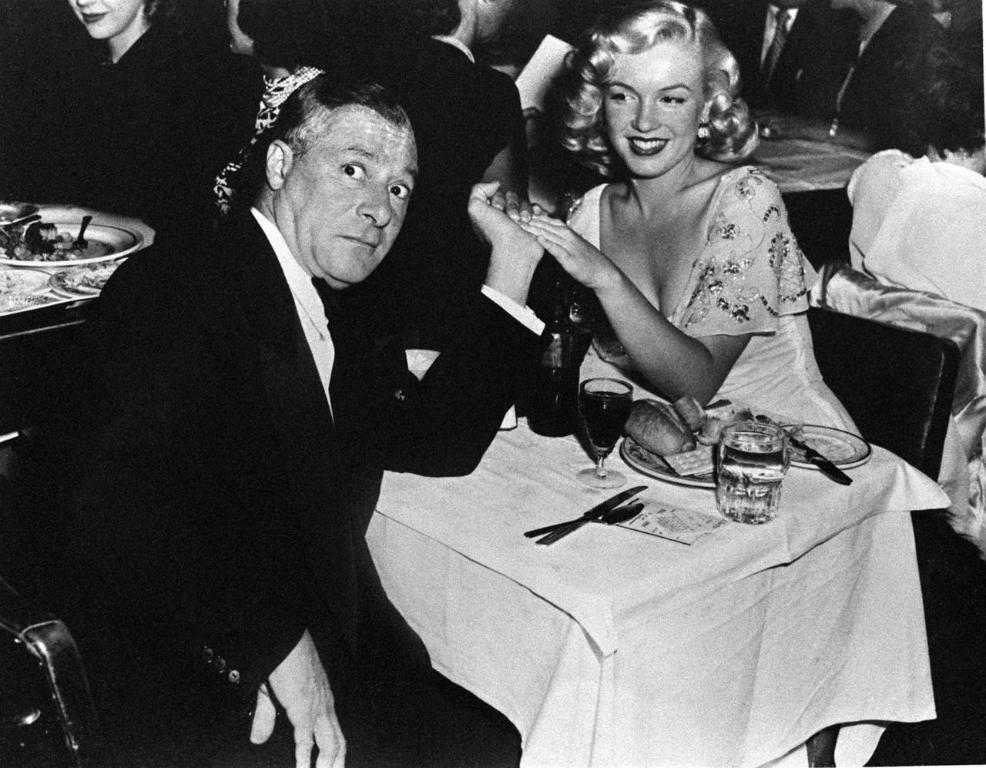What is the color scheme of the image? The image is black and white. Who or what can be seen in the image? There are people in the image. What objects are present in the image that are typically used for eating or drinking? There are glasses, plates, and knives in the image. What is the primary setting of the image? There are objects on tables in the image, suggesting a dining or eating area. What else can be seen in the image that might be related to food or dining? There are chairs in the image, which are commonly found in dining areas. What type of cabbage is being measured on the table in the image? There is no cabbage present in the image, nor is there any measuring activity taking place. 